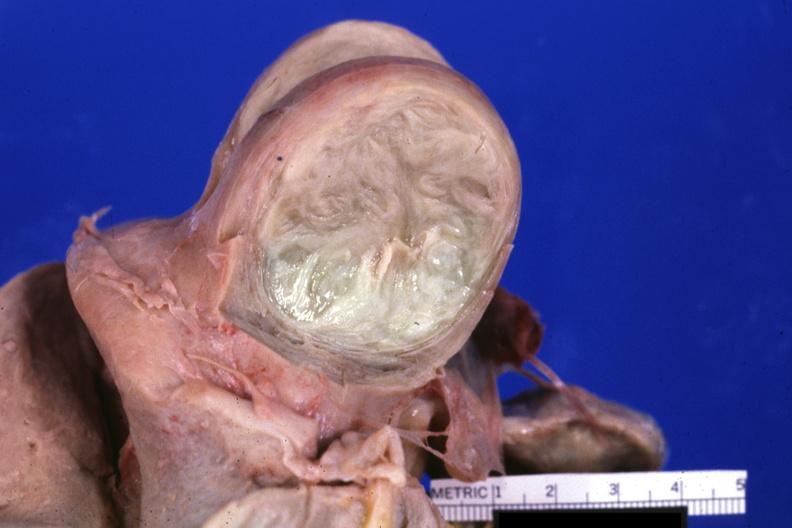how is fixed tissue cut surface of myoma?
Answer the question using a single word or phrase. Typical 